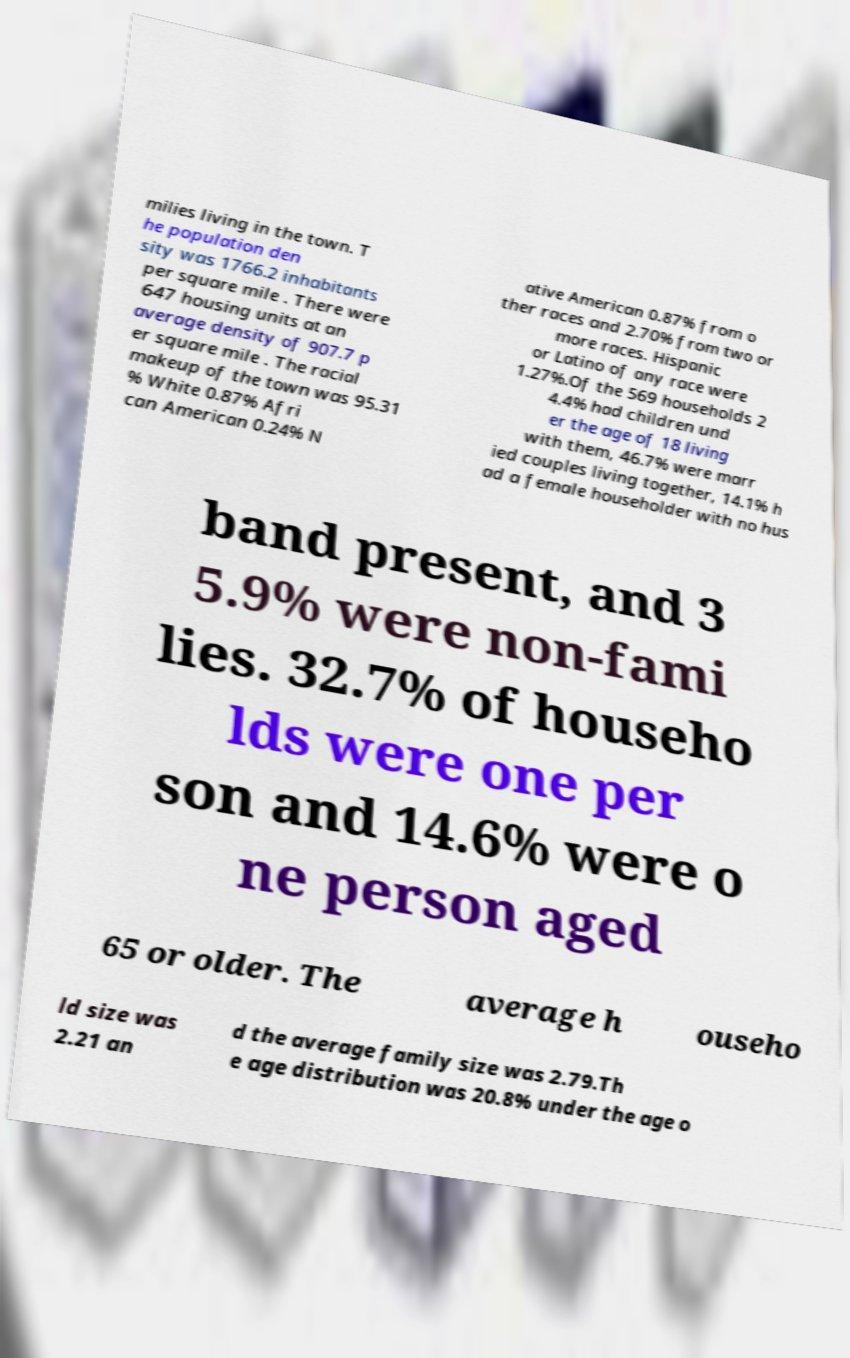Please read and relay the text visible in this image. What does it say? milies living in the town. T he population den sity was 1766.2 inhabitants per square mile . There were 647 housing units at an average density of 907.7 p er square mile . The racial makeup of the town was 95.31 % White 0.87% Afri can American 0.24% N ative American 0.87% from o ther races and 2.70% from two or more races. Hispanic or Latino of any race were 1.27%.Of the 569 households 2 4.4% had children und er the age of 18 living with them, 46.7% were marr ied couples living together, 14.1% h ad a female householder with no hus band present, and 3 5.9% were non-fami lies. 32.7% of househo lds were one per son and 14.6% were o ne person aged 65 or older. The average h ouseho ld size was 2.21 an d the average family size was 2.79.Th e age distribution was 20.8% under the age o 